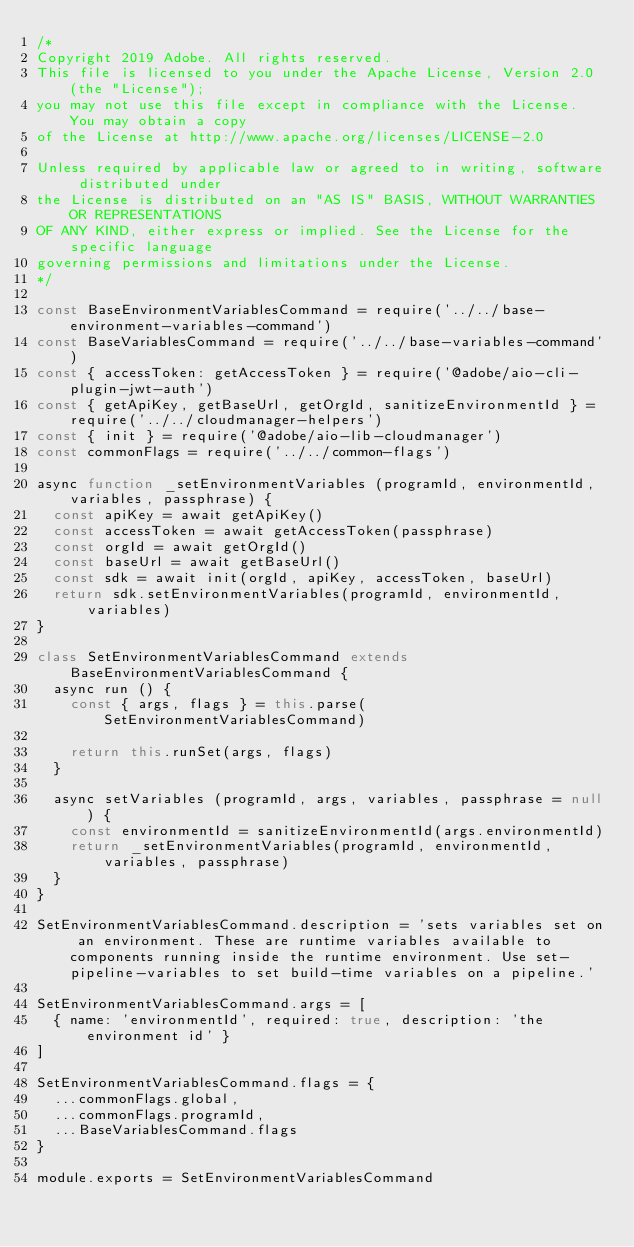Convert code to text. <code><loc_0><loc_0><loc_500><loc_500><_JavaScript_>/*
Copyright 2019 Adobe. All rights reserved.
This file is licensed to you under the Apache License, Version 2.0 (the "License");
you may not use this file except in compliance with the License. You may obtain a copy
of the License at http://www.apache.org/licenses/LICENSE-2.0

Unless required by applicable law or agreed to in writing, software distributed under
the License is distributed on an "AS IS" BASIS, WITHOUT WARRANTIES OR REPRESENTATIONS
OF ANY KIND, either express or implied. See the License for the specific language
governing permissions and limitations under the License.
*/

const BaseEnvironmentVariablesCommand = require('../../base-environment-variables-command')
const BaseVariablesCommand = require('../../base-variables-command')
const { accessToken: getAccessToken } = require('@adobe/aio-cli-plugin-jwt-auth')
const { getApiKey, getBaseUrl, getOrgId, sanitizeEnvironmentId } = require('../../cloudmanager-helpers')
const { init } = require('@adobe/aio-lib-cloudmanager')
const commonFlags = require('../../common-flags')

async function _setEnvironmentVariables (programId, environmentId, variables, passphrase) {
  const apiKey = await getApiKey()
  const accessToken = await getAccessToken(passphrase)
  const orgId = await getOrgId()
  const baseUrl = await getBaseUrl()
  const sdk = await init(orgId, apiKey, accessToken, baseUrl)
  return sdk.setEnvironmentVariables(programId, environmentId, variables)
}

class SetEnvironmentVariablesCommand extends BaseEnvironmentVariablesCommand {
  async run () {
    const { args, flags } = this.parse(SetEnvironmentVariablesCommand)

    return this.runSet(args, flags)
  }

  async setVariables (programId, args, variables, passphrase = null) {
    const environmentId = sanitizeEnvironmentId(args.environmentId)
    return _setEnvironmentVariables(programId, environmentId, variables, passphrase)
  }
}

SetEnvironmentVariablesCommand.description = 'sets variables set on an environment. These are runtime variables available to components running inside the runtime environment. Use set-pipeline-variables to set build-time variables on a pipeline.'

SetEnvironmentVariablesCommand.args = [
  { name: 'environmentId', required: true, description: 'the environment id' }
]

SetEnvironmentVariablesCommand.flags = {
  ...commonFlags.global,
  ...commonFlags.programId,
  ...BaseVariablesCommand.flags
}

module.exports = SetEnvironmentVariablesCommand
</code> 